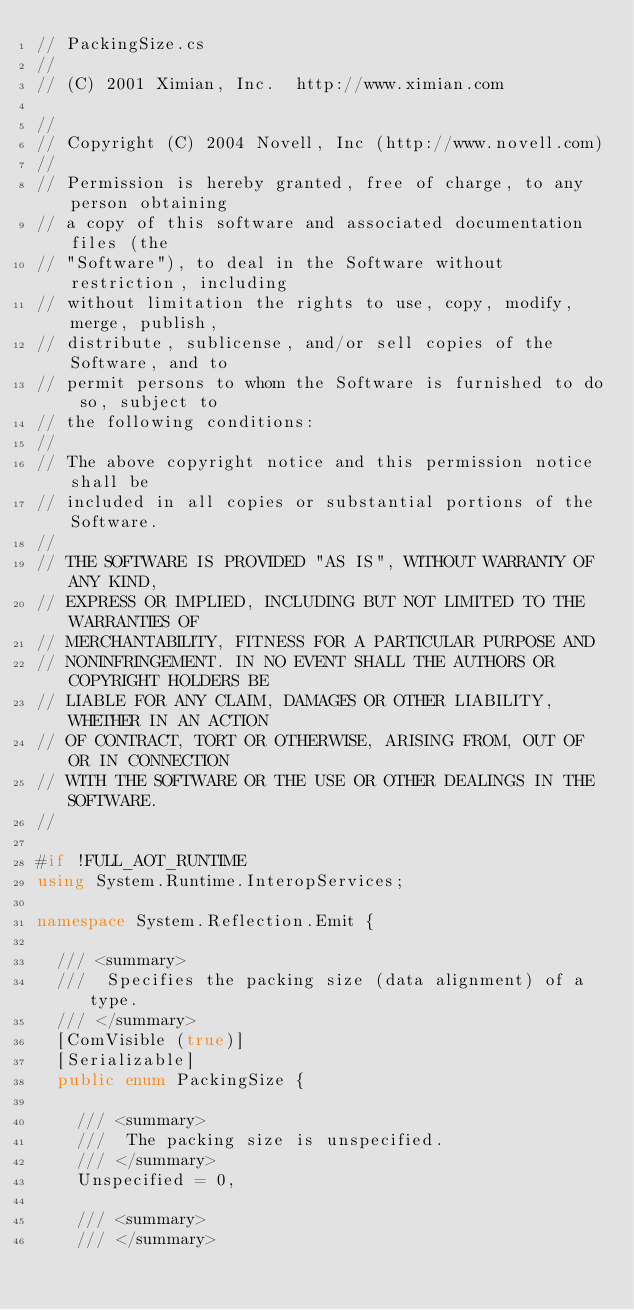<code> <loc_0><loc_0><loc_500><loc_500><_C#_>// PackingSize.cs
//
// (C) 2001 Ximian, Inc.  http://www.ximian.com

//
// Copyright (C) 2004 Novell, Inc (http://www.novell.com)
//
// Permission is hereby granted, free of charge, to any person obtaining
// a copy of this software and associated documentation files (the
// "Software"), to deal in the Software without restriction, including
// without limitation the rights to use, copy, modify, merge, publish,
// distribute, sublicense, and/or sell copies of the Software, and to
// permit persons to whom the Software is furnished to do so, subject to
// the following conditions:
// 
// The above copyright notice and this permission notice shall be
// included in all copies or substantial portions of the Software.
// 
// THE SOFTWARE IS PROVIDED "AS IS", WITHOUT WARRANTY OF ANY KIND,
// EXPRESS OR IMPLIED, INCLUDING BUT NOT LIMITED TO THE WARRANTIES OF
// MERCHANTABILITY, FITNESS FOR A PARTICULAR PURPOSE AND
// NONINFRINGEMENT. IN NO EVENT SHALL THE AUTHORS OR COPYRIGHT HOLDERS BE
// LIABLE FOR ANY CLAIM, DAMAGES OR OTHER LIABILITY, WHETHER IN AN ACTION
// OF CONTRACT, TORT OR OTHERWISE, ARISING FROM, OUT OF OR IN CONNECTION
// WITH THE SOFTWARE OR THE USE OR OTHER DEALINGS IN THE SOFTWARE.
//

#if !FULL_AOT_RUNTIME
using System.Runtime.InteropServices;

namespace System.Reflection.Emit {

	/// <summary>
	///  Specifies the packing size (data alignment) of a type.
	/// </summary>
	[ComVisible (true)]
	[Serializable]
	public enum PackingSize {

		/// <summary>
		///  The packing size is unspecified.
		/// </summary>
		Unspecified = 0,

		/// <summary>
		/// </summary></code> 